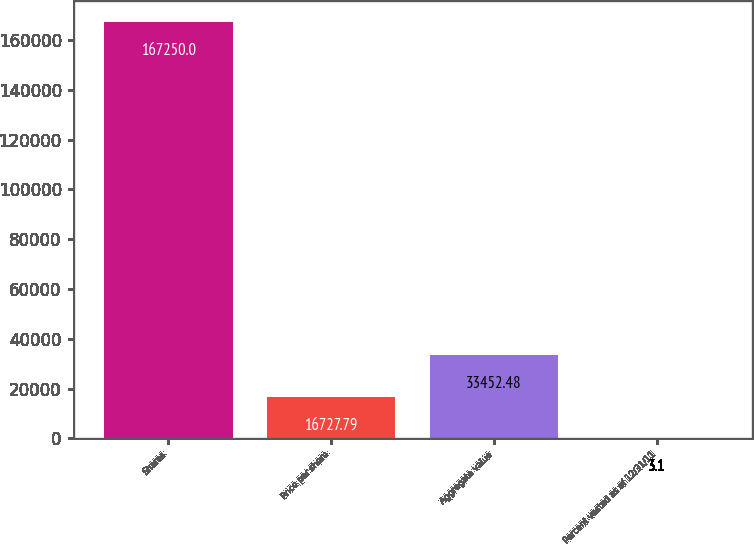Convert chart to OTSL. <chart><loc_0><loc_0><loc_500><loc_500><bar_chart><fcel>Shares<fcel>Price per share<fcel>Aggregate value<fcel>Percent vested as of 12/31/11<nl><fcel>167250<fcel>16727.8<fcel>33452.5<fcel>3.1<nl></chart> 